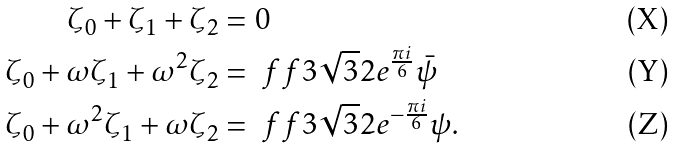<formula> <loc_0><loc_0><loc_500><loc_500>\zeta _ { 0 } + \zeta _ { 1 } + \zeta _ { 2 } & = 0 \\ \zeta _ { 0 } + \omega \zeta _ { 1 } + \omega ^ { 2 } \zeta _ { 2 } & = \ f f { 3 \sqrt { 3 } } { 2 } e ^ { \frac { \pi i } 6 } \bar { \psi } \\ \zeta _ { 0 } + \omega ^ { 2 } \zeta _ { 1 } + \omega \zeta _ { 2 } & = \ f f { 3 \sqrt { 3 } } { 2 } e ^ { - \frac { \pi i } 6 } \psi .</formula> 